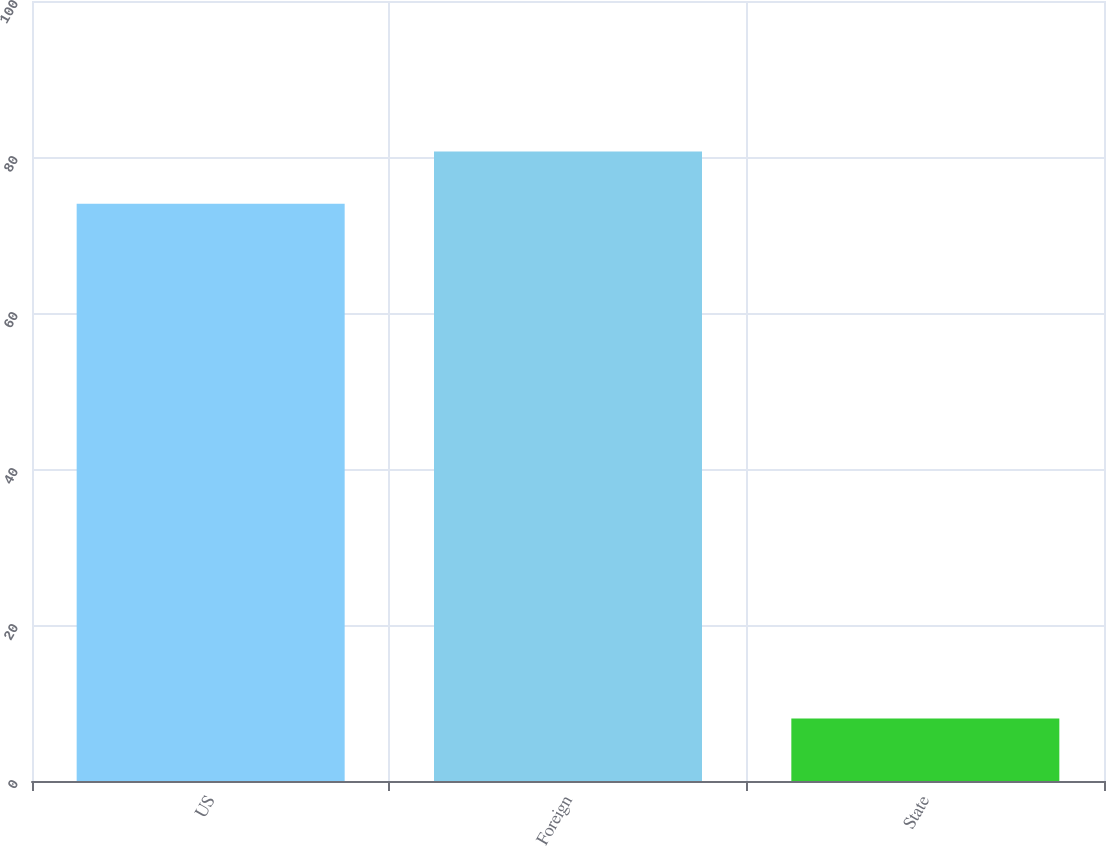<chart> <loc_0><loc_0><loc_500><loc_500><bar_chart><fcel>US<fcel>Foreign<fcel>State<nl><fcel>74<fcel>80.7<fcel>8<nl></chart> 